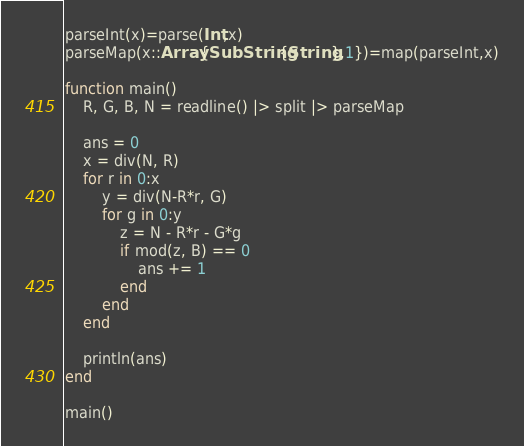Convert code to text. <code><loc_0><loc_0><loc_500><loc_500><_Julia_>parseInt(x)=parse(Int,x)
parseMap(x::Array{SubString{String},1})=map(parseInt,x)
 
function main()
    R, G, B, N = readline() |> split |> parseMap
 
    ans = 0
    x = div(N, R)
    for r in 0:x
        y = div(N-R*r, G)
        for g in 0:y
            z = N - R*r - G*g
            if mod(z, B) == 0
                ans += 1
            end
        end
    end
 
    println(ans)
end

main()</code> 